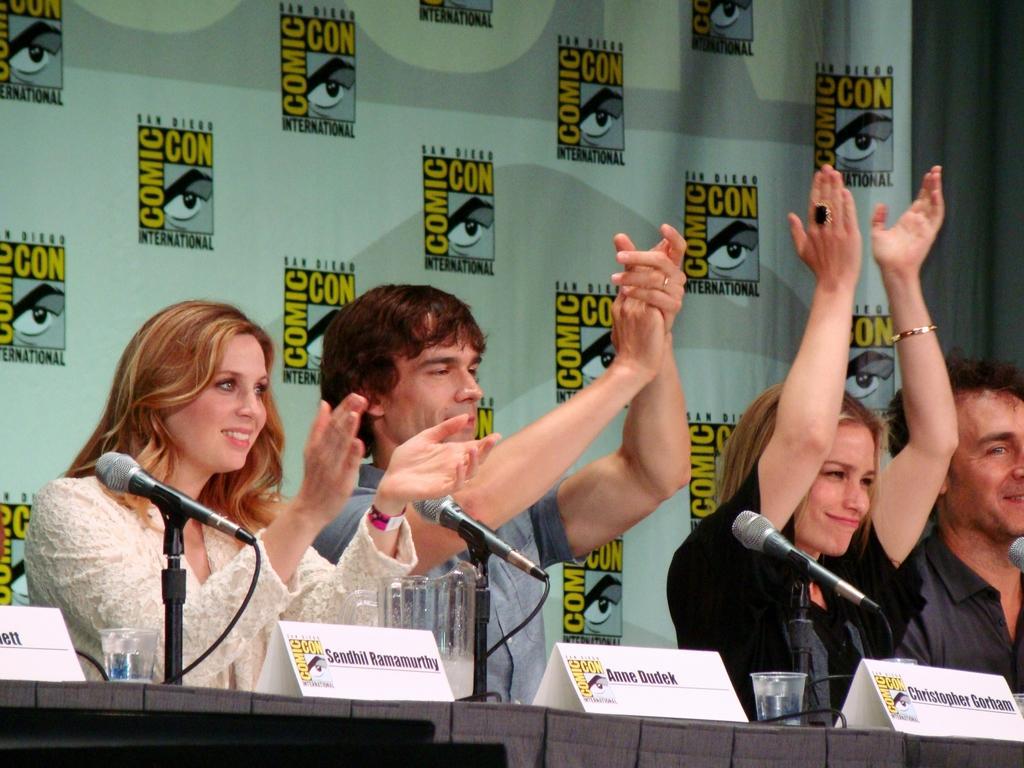Describe this image in one or two sentences. This picture is clicked inside. In the foreground there is a table on the top of which we can see the name plates, glasses containing water and microphones that are attached to the stands. In the center we can see the group of people sitting on the chairs and clapping their hands. In the background there is a curtain and a banner on which we can see the pictures of eyes and the text is printed on the banner. 